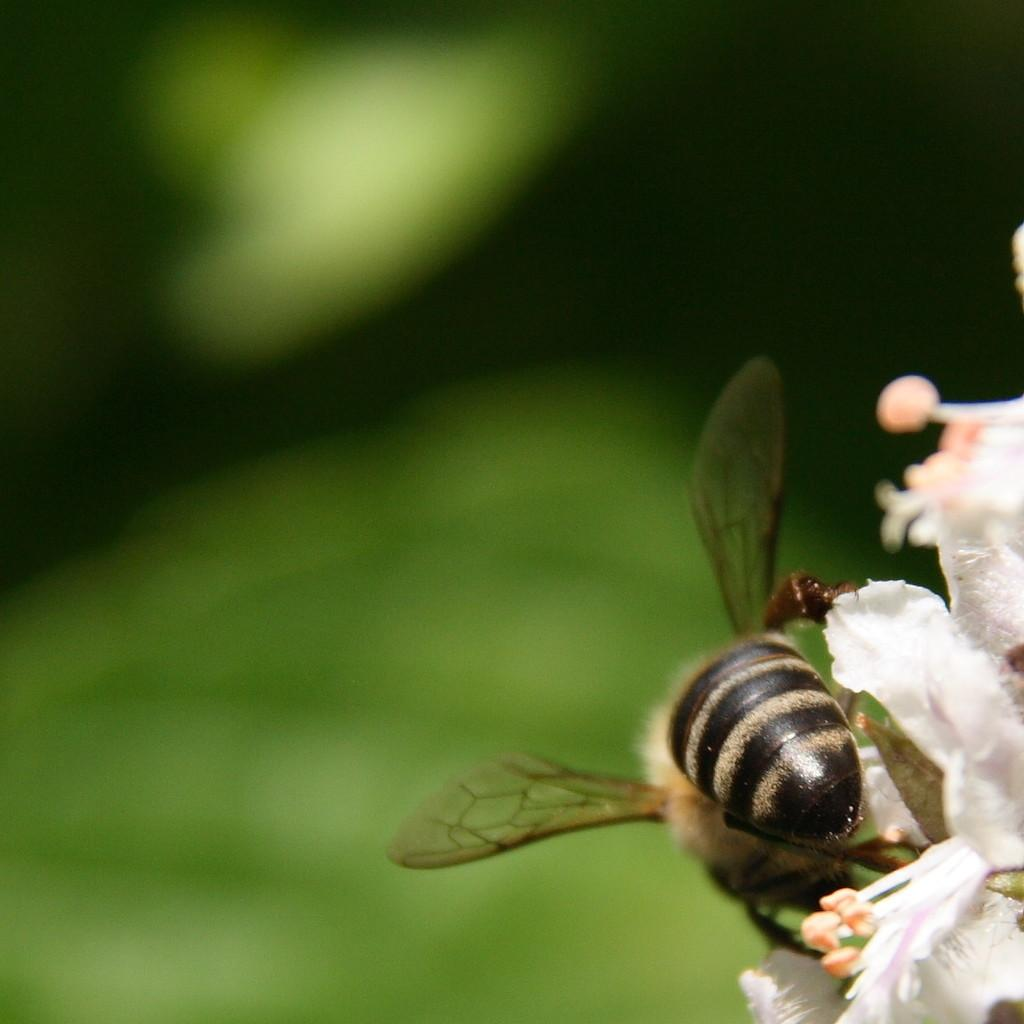What is present on the flower in the image? There is an insect on the flower in the image. What is the insect's location in relation to the flower? The insect is on the flower. Can you describe the background of the image? The background of the image is blurred. What type of station can be seen in the background of the image? There is no station present in the image; the background is blurred. How many yaks are visible in the image? There are no yaks present in the image; it features an insect on a flower. 